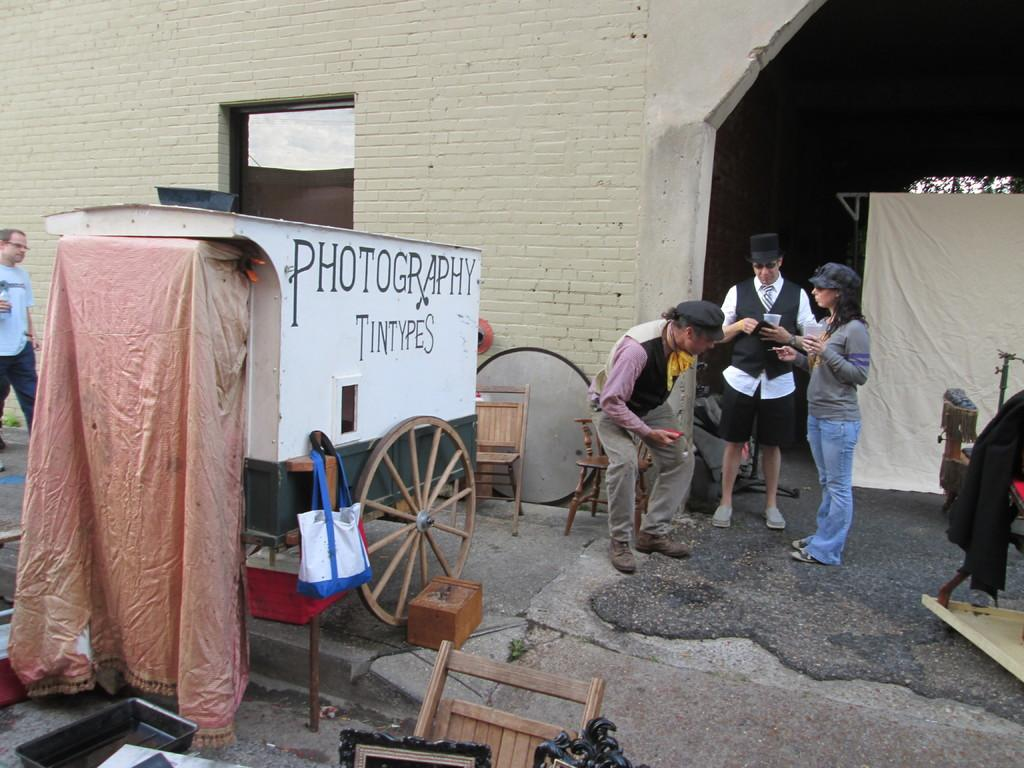What is the main object in the image? There is a cart in the image. How many people are present in the image? There are four persons in the image. What type of furniture is visible in the image? There are chairs in the image. What can be seen in the background of the image? There is a cloth and a wall in the background of the image. What type of vest is the organization wearing in the image? There is no organization or vest present in the image. How many mice can be seen running around the cart in the image? There are no mice present in the image; it features a cart, chairs, and four persons. 